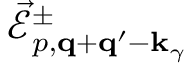<formula> <loc_0><loc_0><loc_500><loc_500>\vec { \mathcal { E } } _ { p , { q } + { q } ^ { \prime } - { k } _ { \gamma } } ^ { \pm }</formula> 